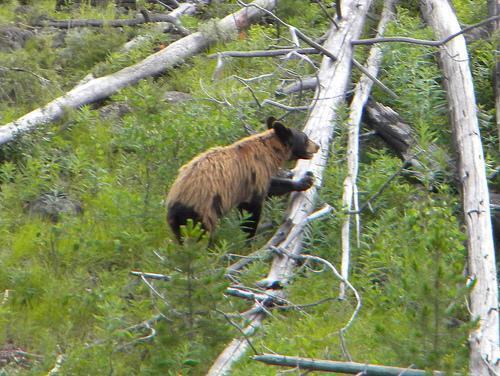How many bears are there?
Give a very brief answer. 1. 